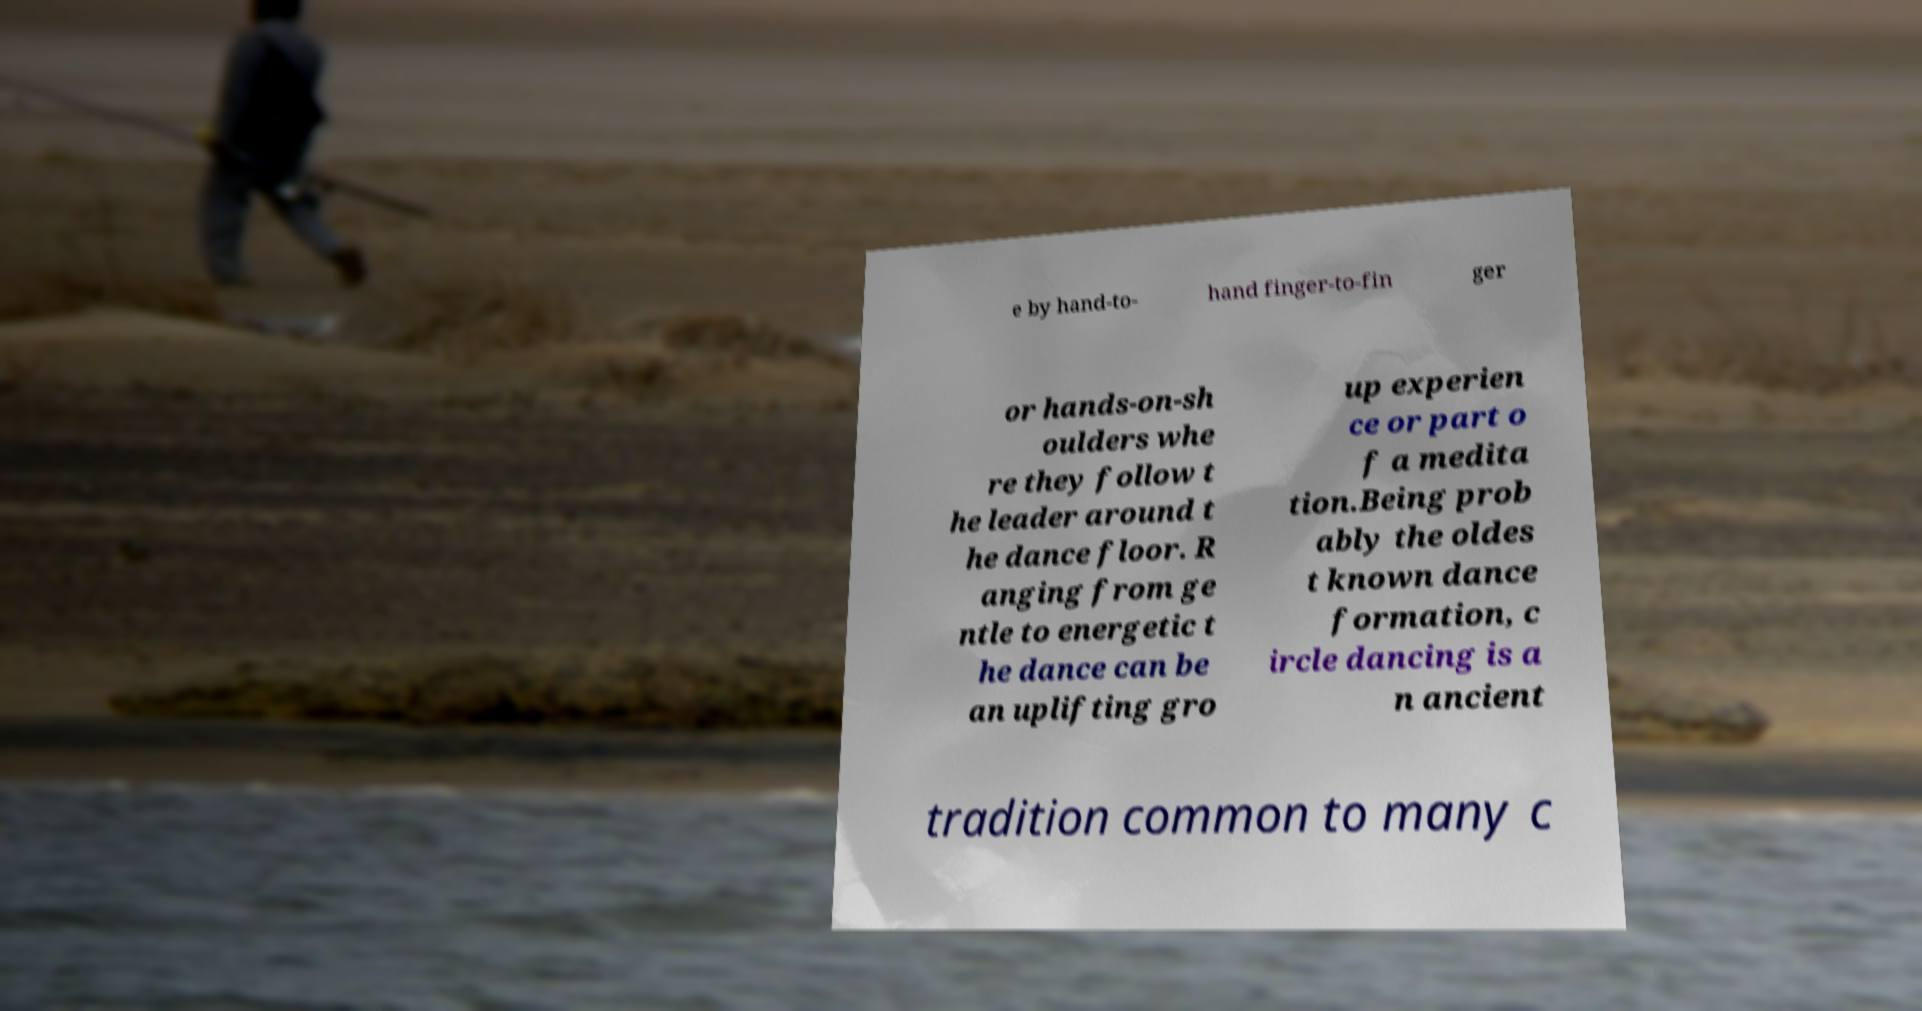I need the written content from this picture converted into text. Can you do that? e by hand-to- hand finger-to-fin ger or hands-on-sh oulders whe re they follow t he leader around t he dance floor. R anging from ge ntle to energetic t he dance can be an uplifting gro up experien ce or part o f a medita tion.Being prob ably the oldes t known dance formation, c ircle dancing is a n ancient tradition common to many c 